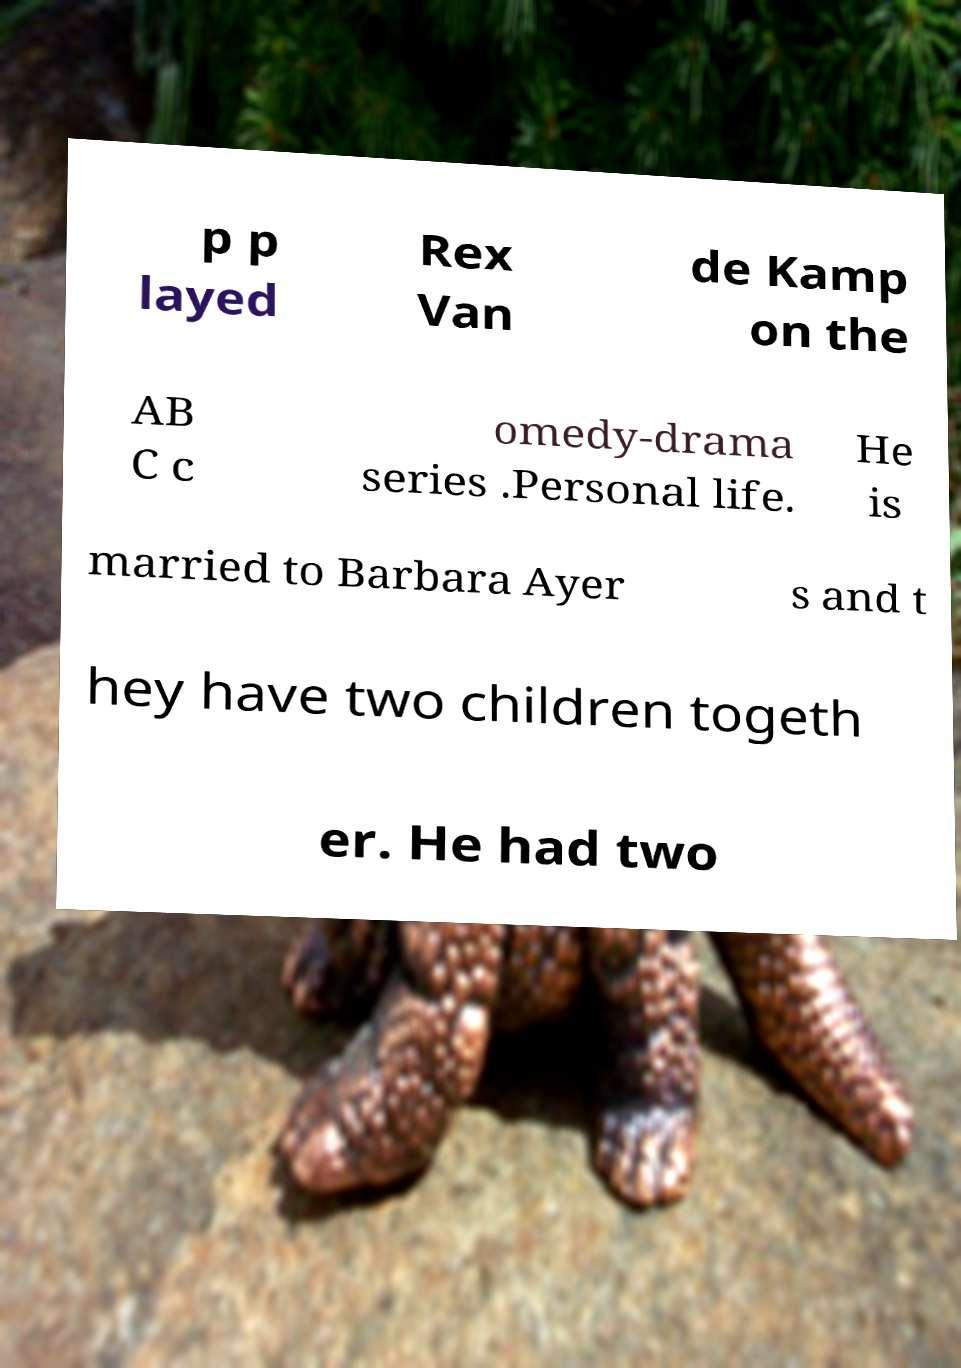For documentation purposes, I need the text within this image transcribed. Could you provide that? p p layed Rex Van de Kamp on the AB C c omedy-drama series .Personal life. He is married to Barbara Ayer s and t hey have two children togeth er. He had two 